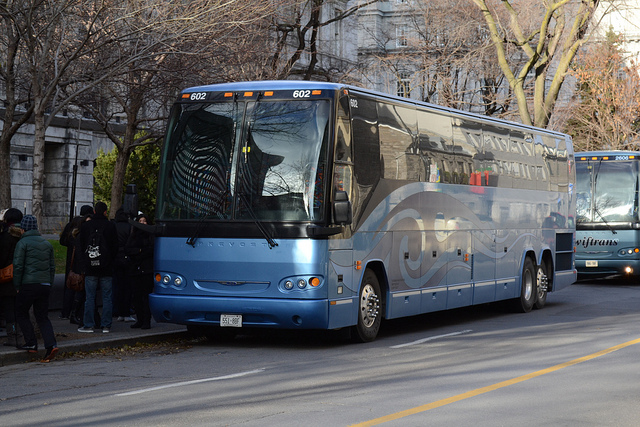What is the primary use of this vehicle? The vehicle in the image is a coach bus, which is primarily used for long-distance travel, providing transportation for groups such as tourists, sports teams, or for intercity travel. 